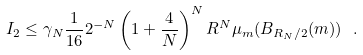Convert formula to latex. <formula><loc_0><loc_0><loc_500><loc_500>I _ { 2 } \leq \gamma _ { N } \frac { 1 } { 1 6 } 2 ^ { - N } \left ( 1 + \frac { 4 } { N } \right ) ^ { N } R ^ { N } \mu _ { m } ( B _ { R _ { N } / 2 } ( m ) ) \ .</formula> 